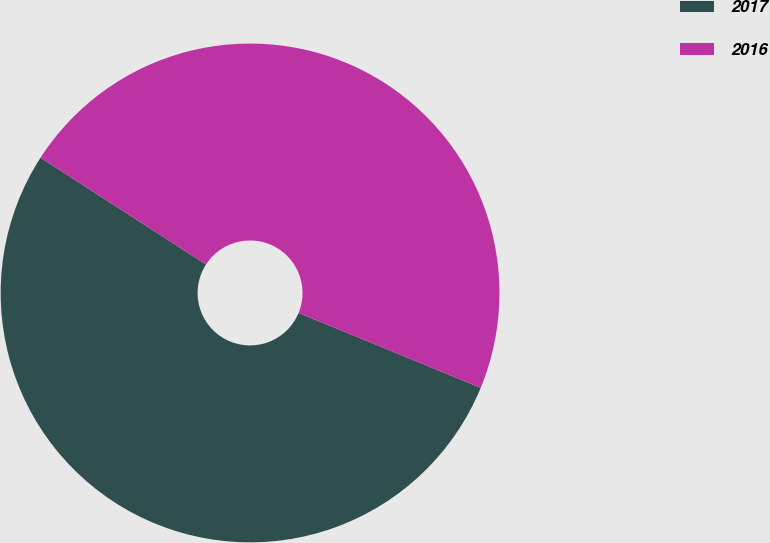<chart> <loc_0><loc_0><loc_500><loc_500><pie_chart><fcel>2017<fcel>2016<nl><fcel>52.91%<fcel>47.09%<nl></chart> 